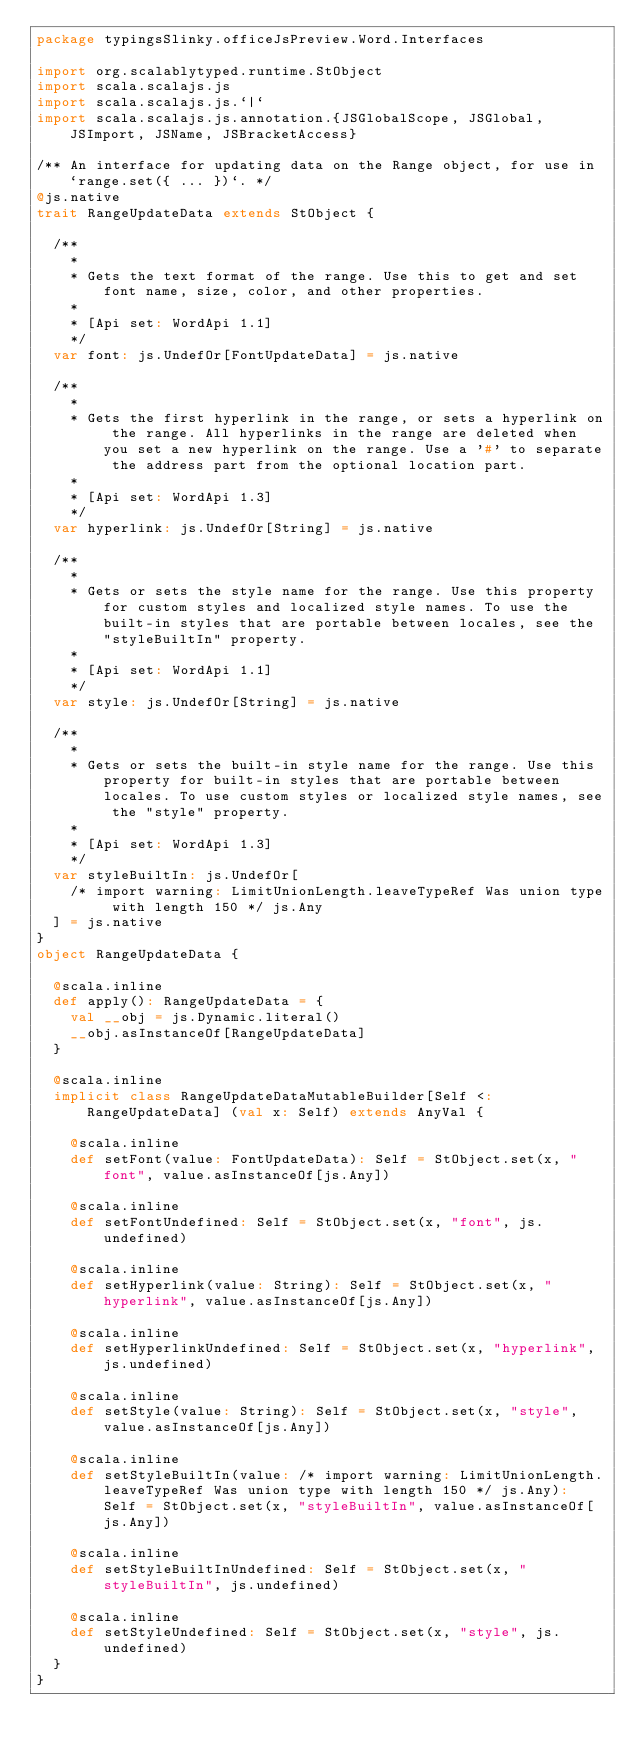Convert code to text. <code><loc_0><loc_0><loc_500><loc_500><_Scala_>package typingsSlinky.officeJsPreview.Word.Interfaces

import org.scalablytyped.runtime.StObject
import scala.scalajs.js
import scala.scalajs.js.`|`
import scala.scalajs.js.annotation.{JSGlobalScope, JSGlobal, JSImport, JSName, JSBracketAccess}

/** An interface for updating data on the Range object, for use in `range.set({ ... })`. */
@js.native
trait RangeUpdateData extends StObject {
  
  /**
    *
    * Gets the text format of the range. Use this to get and set font name, size, color, and other properties.
    *
    * [Api set: WordApi 1.1]
    */
  var font: js.UndefOr[FontUpdateData] = js.native
  
  /**
    *
    * Gets the first hyperlink in the range, or sets a hyperlink on the range. All hyperlinks in the range are deleted when you set a new hyperlink on the range. Use a '#' to separate the address part from the optional location part.
    *
    * [Api set: WordApi 1.3]
    */
  var hyperlink: js.UndefOr[String] = js.native
  
  /**
    *
    * Gets or sets the style name for the range. Use this property for custom styles and localized style names. To use the built-in styles that are portable between locales, see the "styleBuiltIn" property.
    *
    * [Api set: WordApi 1.1]
    */
  var style: js.UndefOr[String] = js.native
  
  /**
    *
    * Gets or sets the built-in style name for the range. Use this property for built-in styles that are portable between locales. To use custom styles or localized style names, see the "style" property.
    *
    * [Api set: WordApi 1.3]
    */
  var styleBuiltIn: js.UndefOr[
    /* import warning: LimitUnionLength.leaveTypeRef Was union type with length 150 */ js.Any
  ] = js.native
}
object RangeUpdateData {
  
  @scala.inline
  def apply(): RangeUpdateData = {
    val __obj = js.Dynamic.literal()
    __obj.asInstanceOf[RangeUpdateData]
  }
  
  @scala.inline
  implicit class RangeUpdateDataMutableBuilder[Self <: RangeUpdateData] (val x: Self) extends AnyVal {
    
    @scala.inline
    def setFont(value: FontUpdateData): Self = StObject.set(x, "font", value.asInstanceOf[js.Any])
    
    @scala.inline
    def setFontUndefined: Self = StObject.set(x, "font", js.undefined)
    
    @scala.inline
    def setHyperlink(value: String): Self = StObject.set(x, "hyperlink", value.asInstanceOf[js.Any])
    
    @scala.inline
    def setHyperlinkUndefined: Self = StObject.set(x, "hyperlink", js.undefined)
    
    @scala.inline
    def setStyle(value: String): Self = StObject.set(x, "style", value.asInstanceOf[js.Any])
    
    @scala.inline
    def setStyleBuiltIn(value: /* import warning: LimitUnionLength.leaveTypeRef Was union type with length 150 */ js.Any): Self = StObject.set(x, "styleBuiltIn", value.asInstanceOf[js.Any])
    
    @scala.inline
    def setStyleBuiltInUndefined: Self = StObject.set(x, "styleBuiltIn", js.undefined)
    
    @scala.inline
    def setStyleUndefined: Self = StObject.set(x, "style", js.undefined)
  }
}
</code> 